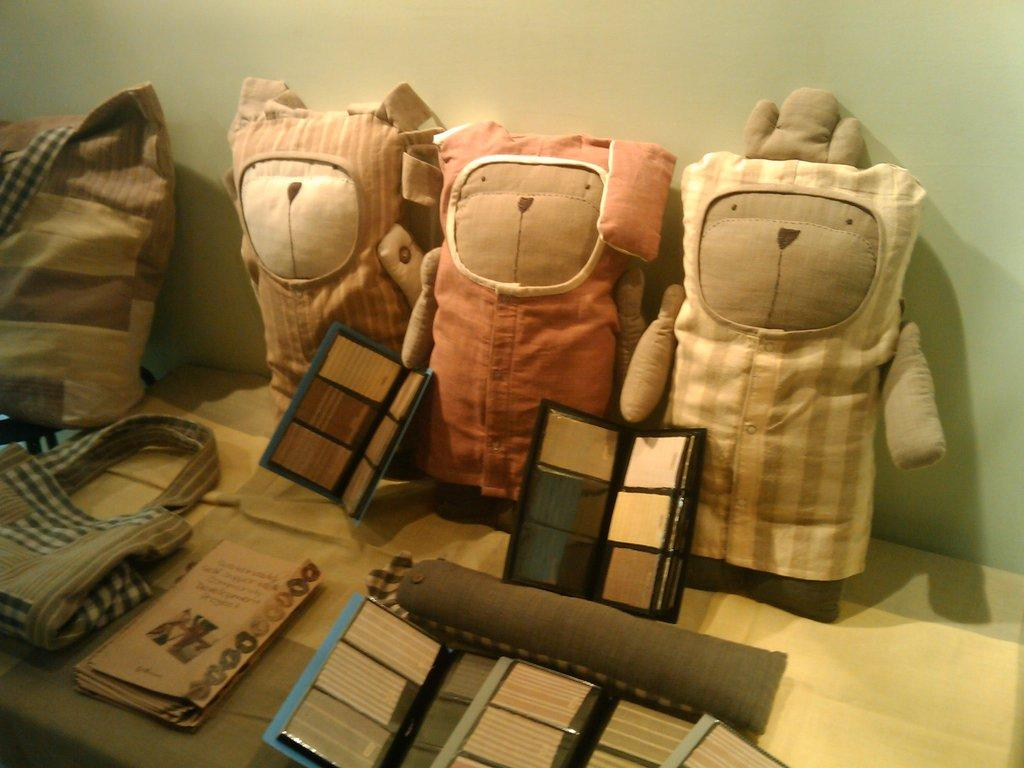What items can be seen on the table in the image? There are papers, toys, and bags on the table in the image. Are there any other objects on the table besides the mentioned items? Yes, there are other objects on the table. What can be seen in the background of the image? There is a wall in the background of the image. What month is it in the image? The month cannot be determined from the image, as there is no information provided about the time or season. Is there a stick used for care in the image? There is no stick or any indication of care-related activities present in the image. 